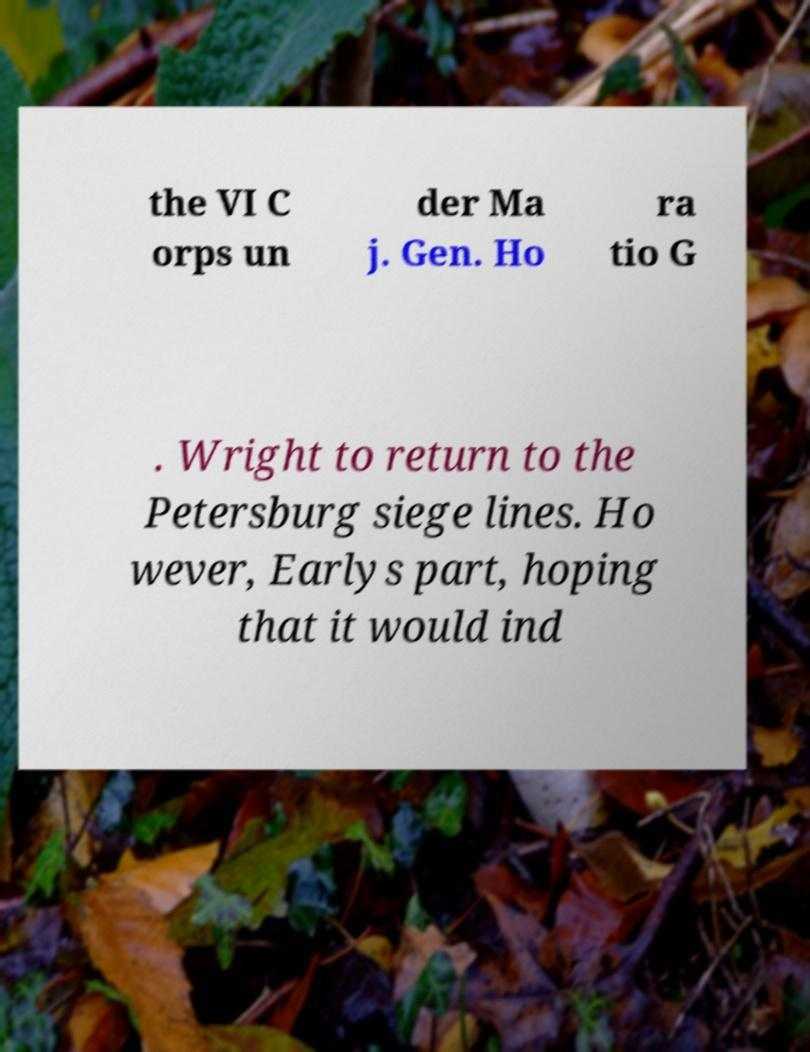Please read and relay the text visible in this image. What does it say? the VI C orps un der Ma j. Gen. Ho ra tio G . Wright to return to the Petersburg siege lines. Ho wever, Earlys part, hoping that it would ind 